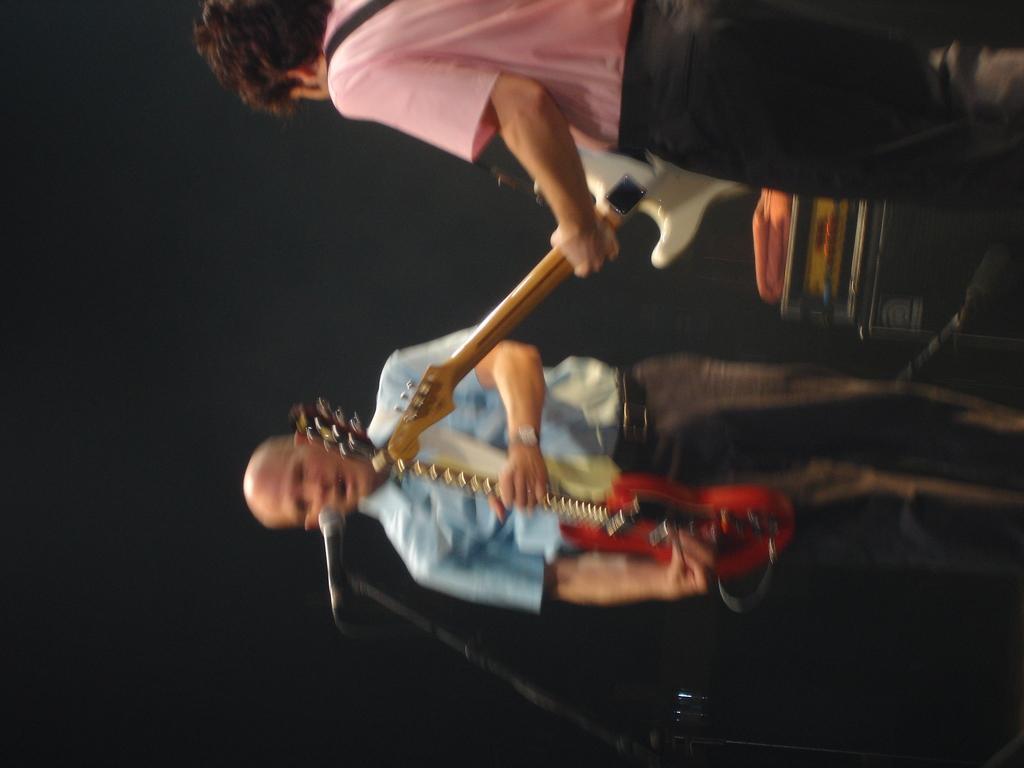In one or two sentences, can you explain what this image depicts? In this image we can see there are two people playing guitars, and there is a mike. 